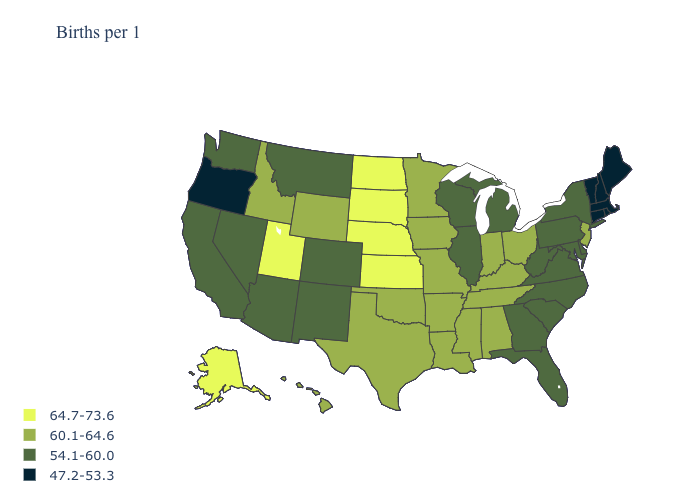Name the states that have a value in the range 60.1-64.6?
Give a very brief answer. Alabama, Arkansas, Hawaii, Idaho, Indiana, Iowa, Kentucky, Louisiana, Minnesota, Mississippi, Missouri, New Jersey, Ohio, Oklahoma, Tennessee, Texas, Wyoming. Name the states that have a value in the range 47.2-53.3?
Answer briefly. Connecticut, Maine, Massachusetts, New Hampshire, Oregon, Rhode Island, Vermont. Does Illinois have the same value as Connecticut?
Write a very short answer. No. Among the states that border Iowa , which have the lowest value?
Quick response, please. Illinois, Wisconsin. Does Kansas have the highest value in the USA?
Answer briefly. Yes. Among the states that border California , does Arizona have the highest value?
Keep it brief. Yes. Does Connecticut have the same value as Wisconsin?
Keep it brief. No. What is the value of Pennsylvania?
Be succinct. 54.1-60.0. What is the value of Colorado?
Quick response, please. 54.1-60.0. Name the states that have a value in the range 47.2-53.3?
Be succinct. Connecticut, Maine, Massachusetts, New Hampshire, Oregon, Rhode Island, Vermont. Among the states that border California , does Nevada have the lowest value?
Short answer required. No. Among the states that border Nebraska , does Colorado have the lowest value?
Answer briefly. Yes. How many symbols are there in the legend?
Concise answer only. 4. Does Rhode Island have the lowest value in the USA?
Keep it brief. Yes. What is the value of Iowa?
Quick response, please. 60.1-64.6. 